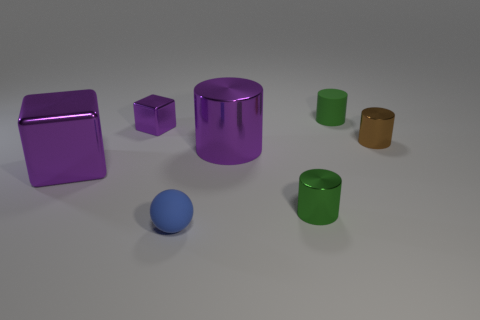Are the tiny cylinder that is to the right of the matte cylinder and the green cylinder that is in front of the small green rubber object made of the same material?
Give a very brief answer. Yes. What is the size of the shiny block that is in front of the small purple shiny object?
Provide a short and direct response. Large. There is a large purple thing that is the same shape as the tiny brown shiny object; what is its material?
Offer a very short reply. Metal. There is a tiny green thing that is behind the tiny brown metallic object; what shape is it?
Keep it short and to the point. Cylinder. What number of large purple metallic things are the same shape as the green metal thing?
Offer a terse response. 1. Are there an equal number of brown metal cylinders that are to the left of the ball and big metal things that are in front of the small purple metal object?
Ensure brevity in your answer.  No. Are there any large brown spheres made of the same material as the brown cylinder?
Keep it short and to the point. No. Is the material of the big purple block the same as the small purple cube?
Provide a short and direct response. Yes. What number of red objects are small metallic cubes or tiny metal cylinders?
Ensure brevity in your answer.  0. Are there more small metal things in front of the large shiny cube than red metal objects?
Provide a short and direct response. Yes. 